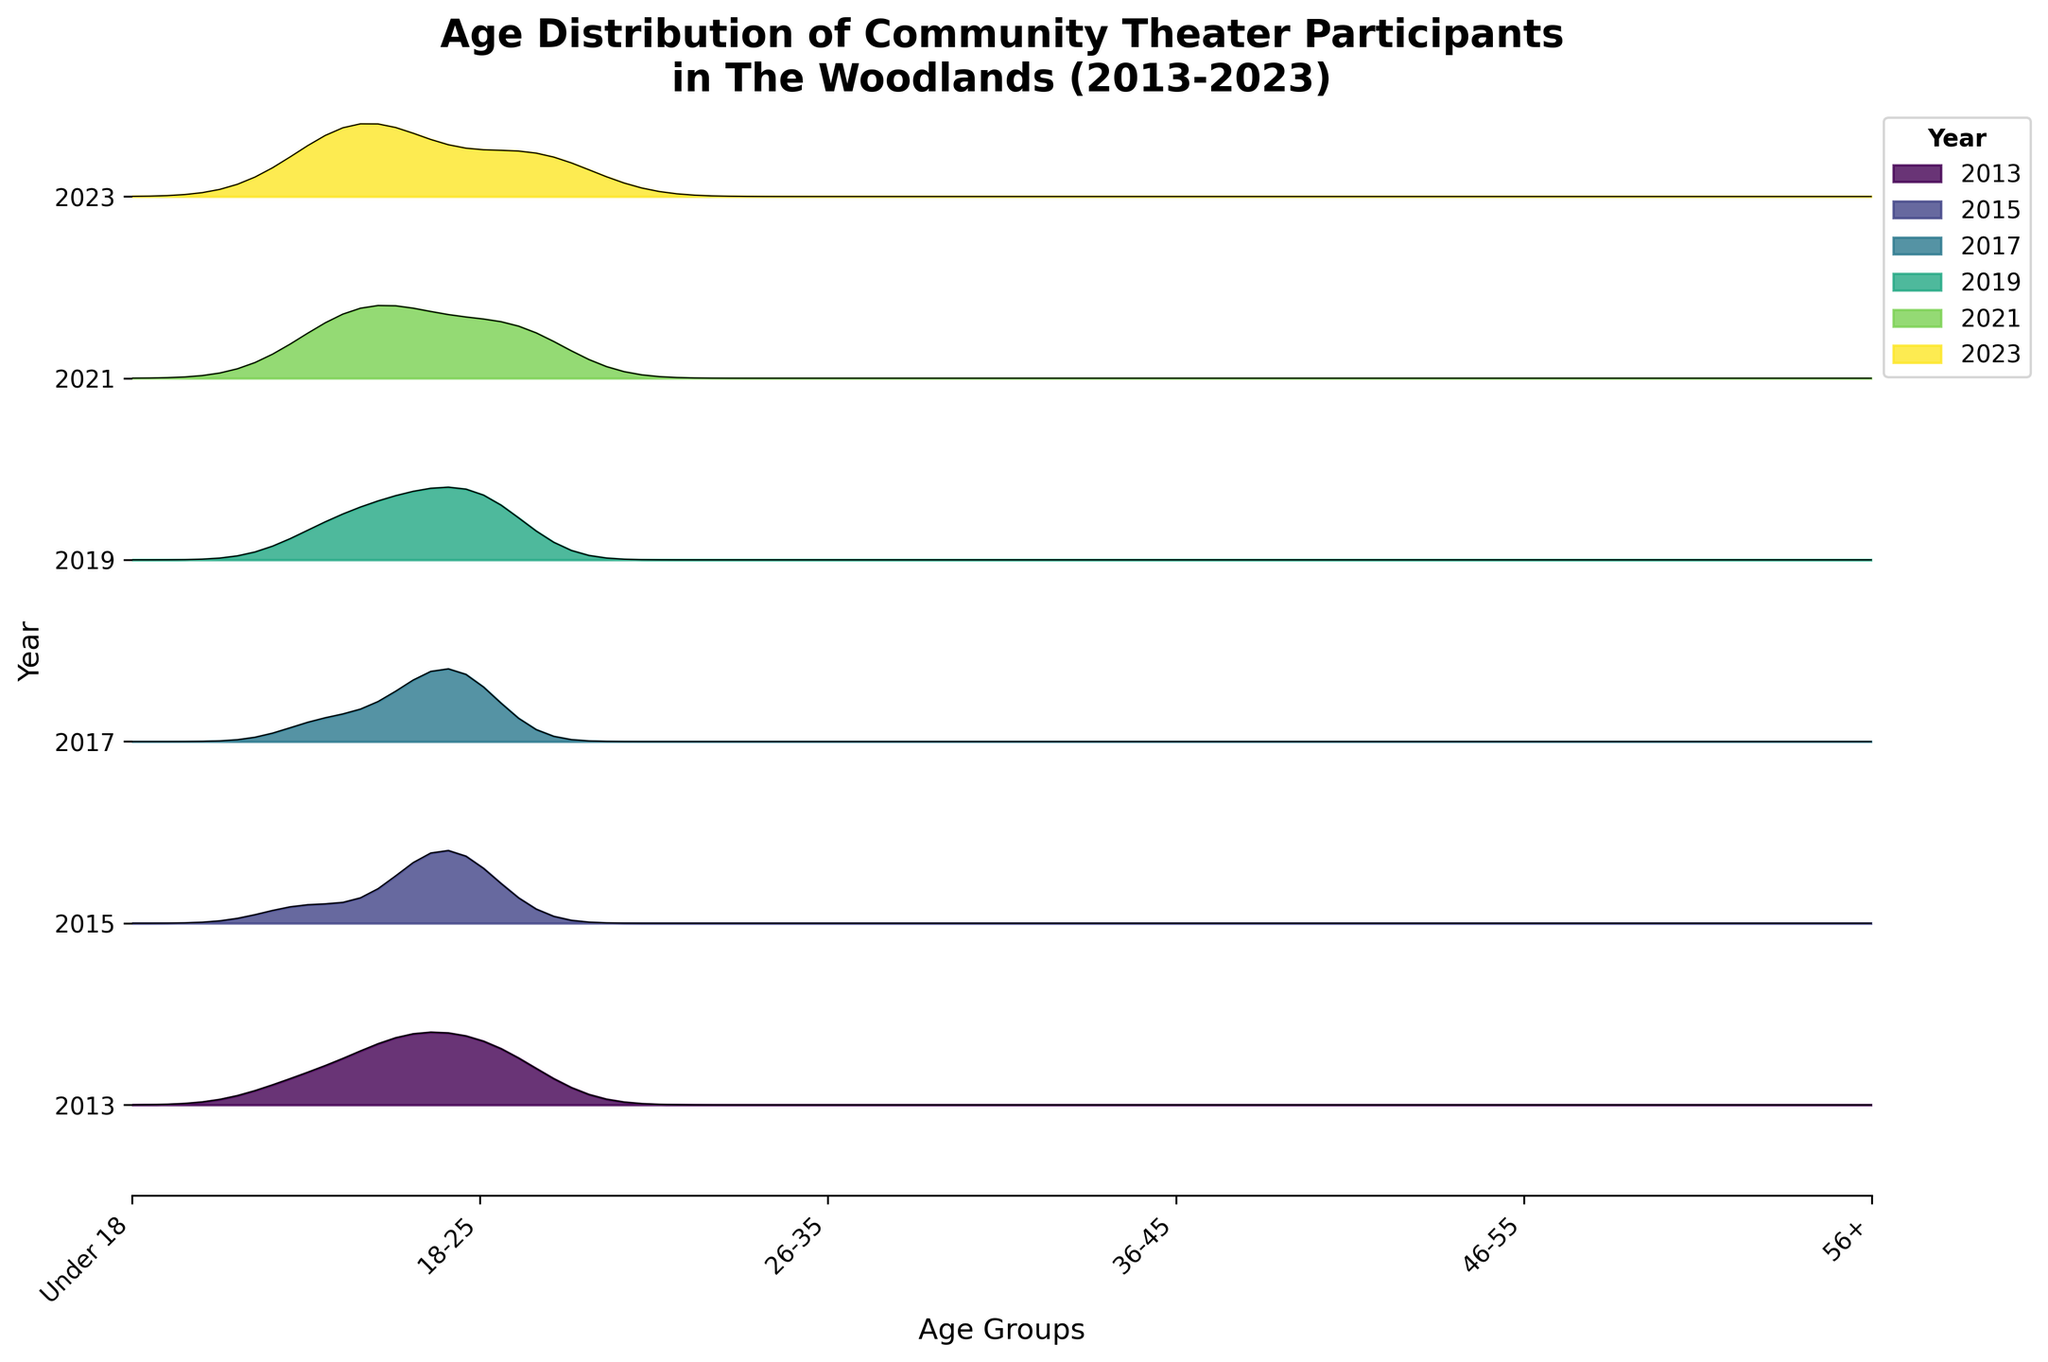What is the title of the plot? The title is displayed prominently at the top of the plot. It reads "Age Distribution of Community Theater Participants in The Woodlands (2013-2023)"
Answer: Age Distribution of Community Theater Participants in The Woodlands (2013-2023) Which age group had the highest density in 2023? To find the highest density for 2023, locate the ridgeline for 2023 and identify the peak. The age group at the peak position on the x-axis will be the one with the highest density.
Answer: 26-35 How did the density of participants aged 18-25 change from 2013 to 2023? Compare the height of the ridgeline for the age group 18-25 between the years 2013 and 2023. In 2013 it is a peak (0.22), and in 2023 it is lower (0.16). Hence, it decreased over time.
Answer: Decreased What is the general trend in the density for the age group 'Under 18' over the years? Observe the position of the 'Under 18' group across all the years from 2013 to 2023. The overall height of the ridgeline for this group increases over time.
Answer: Increasing Which age groups consistently have the same density beginnings and endings across all years? Observing all age groups across all years, those that ended with the same density values of 0.10 in 2013, 2015, 2017, and remained lower are '56+'. This group begins with these values regardless of the year.
Answer: 56+ In which year did the age group '26-35' reach its highest density? The ridgeline with the highest peak for the '26-35' group occurs when comparing all years. In 2021 and 2023, '26-35' reaches highest peaks at 0.22 and 0.23 respectively, whereas 2023 is the highest.
Answer: 2023 Which year had the lowest density for the '46-55' age group, and what was it? Examine each ridgeline for the '46-55' age category and identify the lowest value. In 2023, the density for '46-55' is the lowest at 0.12.
Answer: 2023, 0.12 How does the density distribution for the '56+' age group in 2017 compare with that in 2023? Look at the density values for '56+' in the years 2017 and 2023. Both years have a value of 0.11 for 2017 and 0.12 for 2023, with 2023 being slightly higher.
Answer: 2017 is lower Which age group shows the most significant increase in density from 2013 to 2023? Compare the density values of each age group from 2013 to 2023. The 'Under 18' group grows from 0.15 in 2013 to 0.23 in 2023, showing the greatest increase of 0.08.
Answer: Under 18 